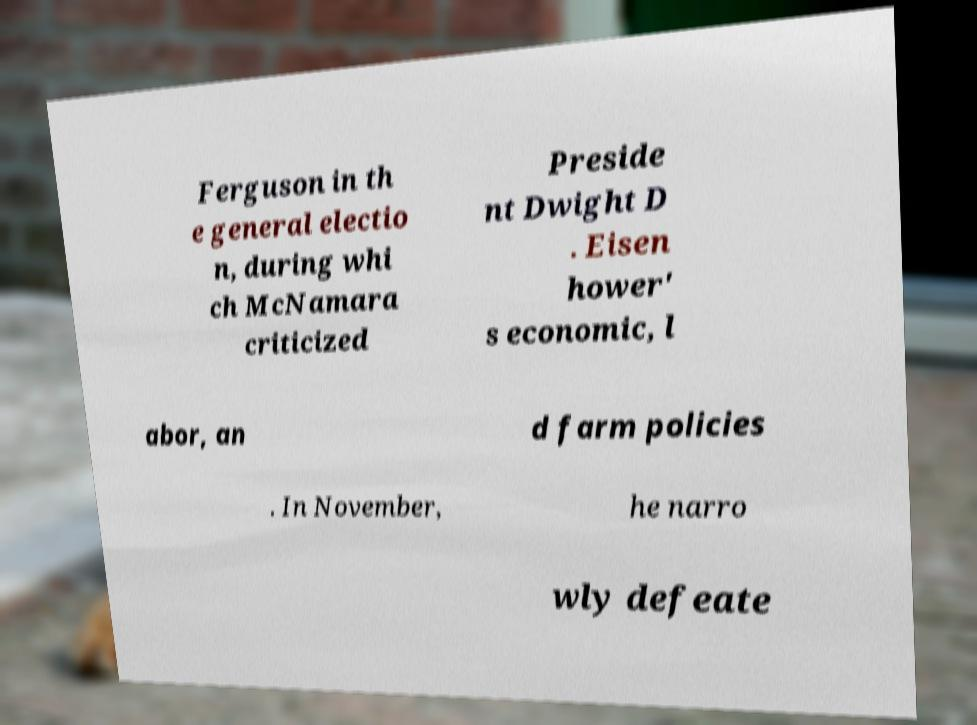What messages or text are displayed in this image? I need them in a readable, typed format. Ferguson in th e general electio n, during whi ch McNamara criticized Preside nt Dwight D . Eisen hower' s economic, l abor, an d farm policies . In November, he narro wly defeate 